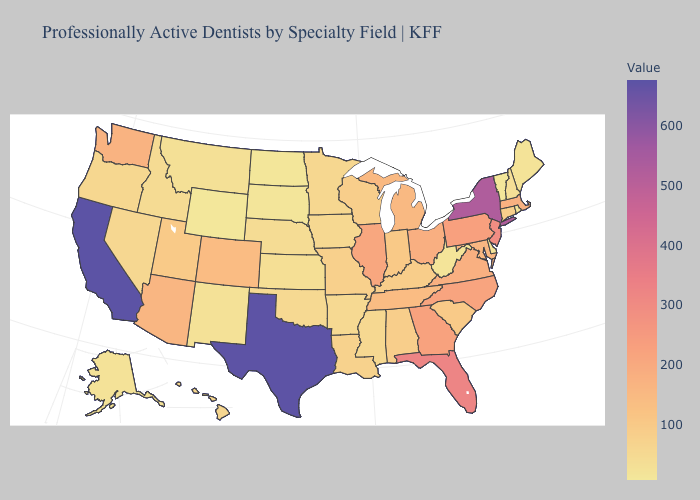Which states have the lowest value in the USA?
Quick response, please. Wyoming. Does Maine have the highest value in the Northeast?
Give a very brief answer. No. Which states have the highest value in the USA?
Concise answer only. California. 